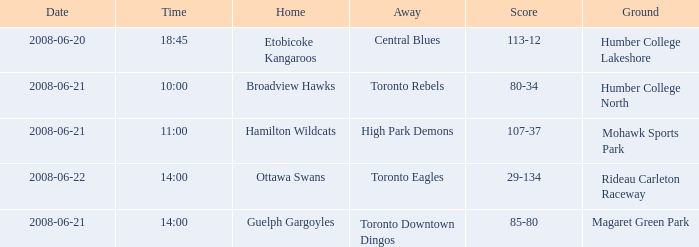What is the Time with a Score that is 80-34? 10:00. 